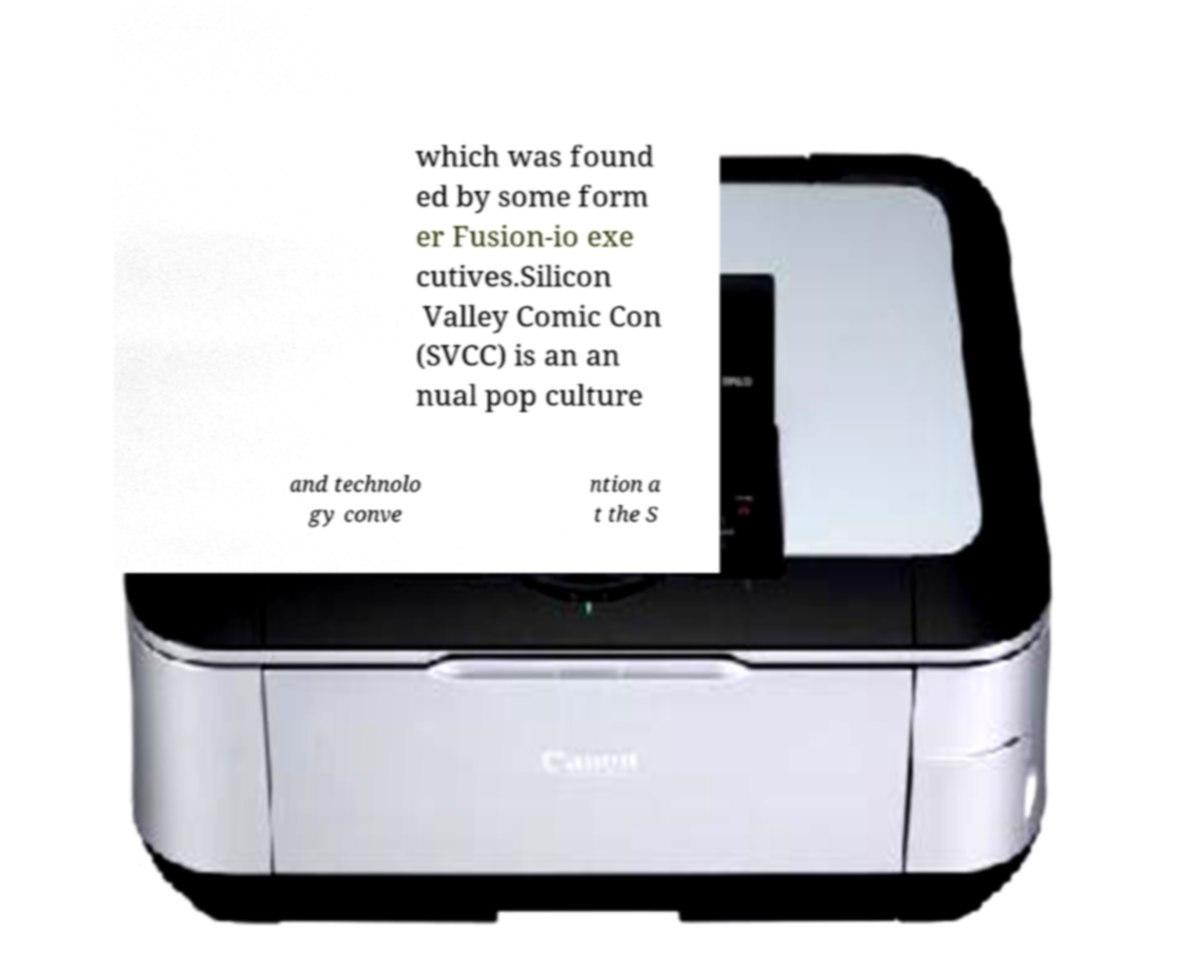Can you read and provide the text displayed in the image?This photo seems to have some interesting text. Can you extract and type it out for me? which was found ed by some form er Fusion-io exe cutives.Silicon Valley Comic Con (SVCC) is an an nual pop culture and technolo gy conve ntion a t the S 